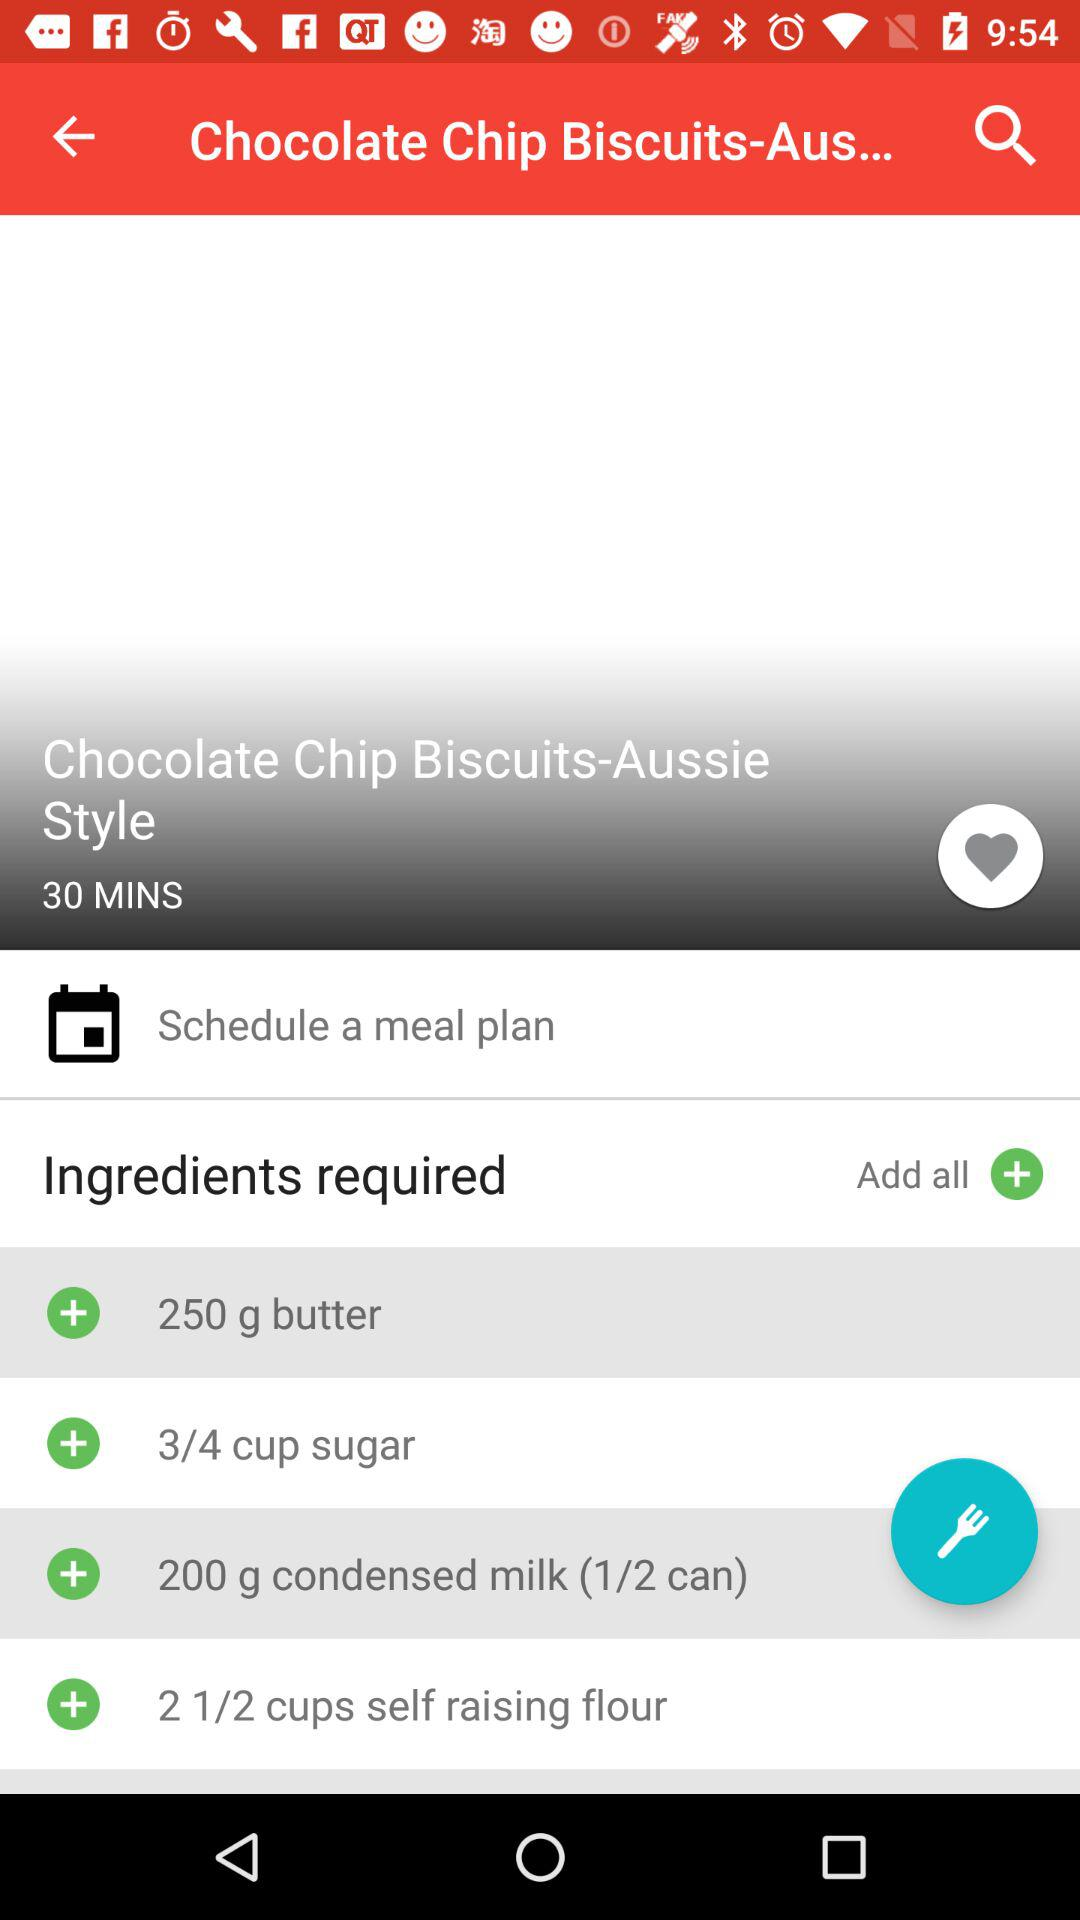How many grams of butter is required? The amount of butter required is 250 grams. 